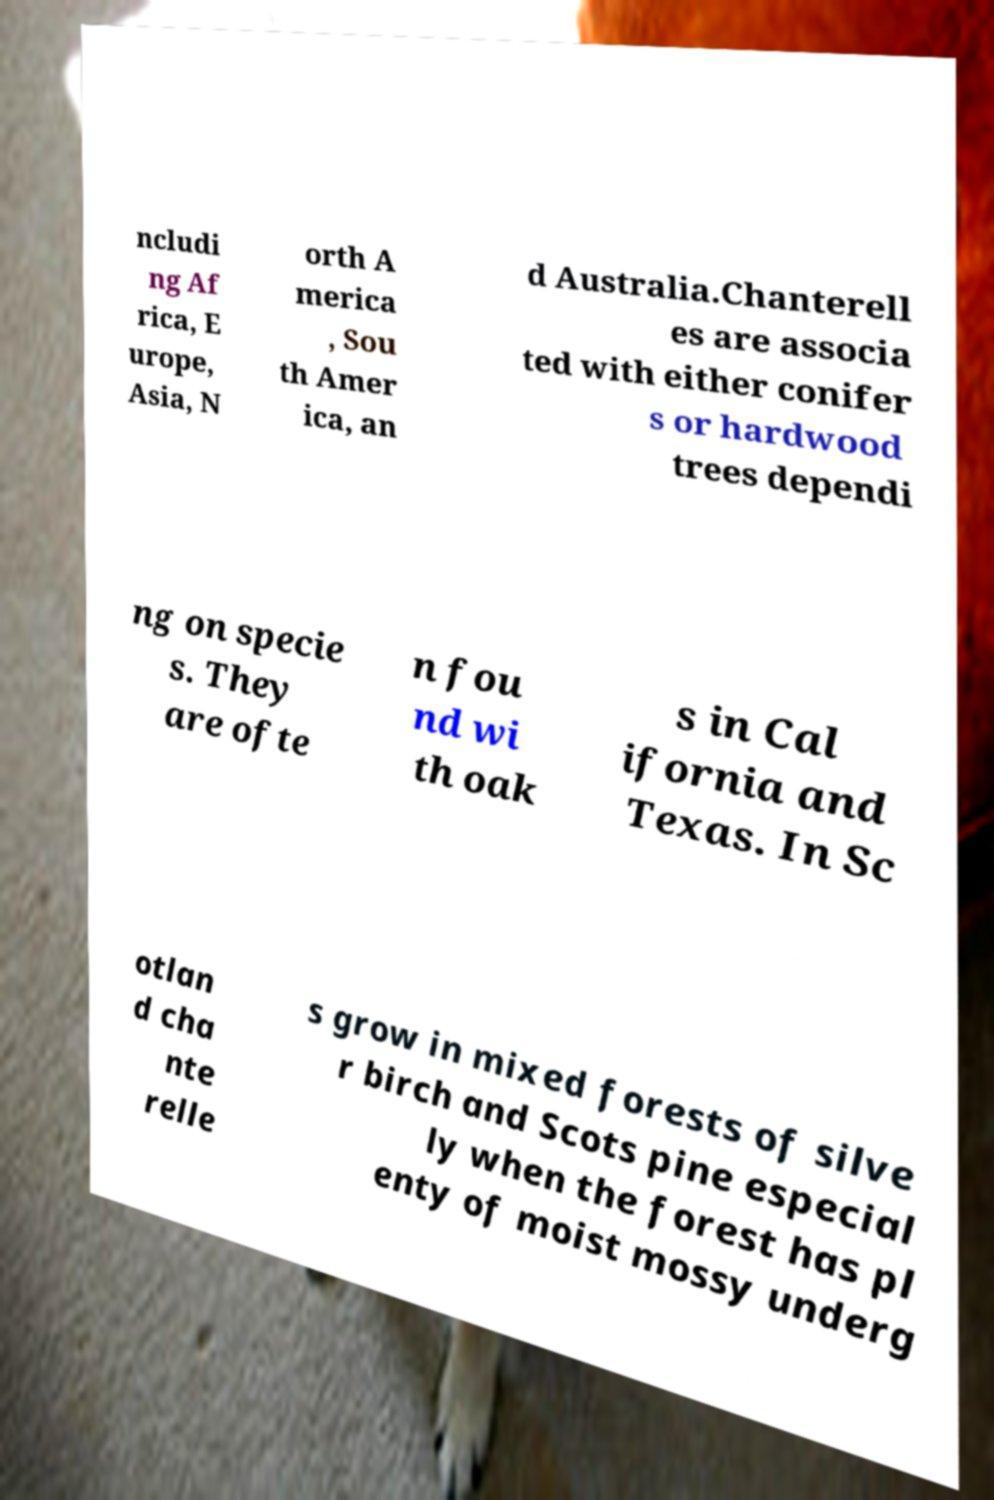Please read and relay the text visible in this image. What does it say? ncludi ng Af rica, E urope, Asia, N orth A merica , Sou th Amer ica, an d Australia.Chanterell es are associa ted with either conifer s or hardwood trees dependi ng on specie s. They are ofte n fou nd wi th oak s in Cal ifornia and Texas. In Sc otlan d cha nte relle s grow in mixed forests of silve r birch and Scots pine especial ly when the forest has pl enty of moist mossy underg 